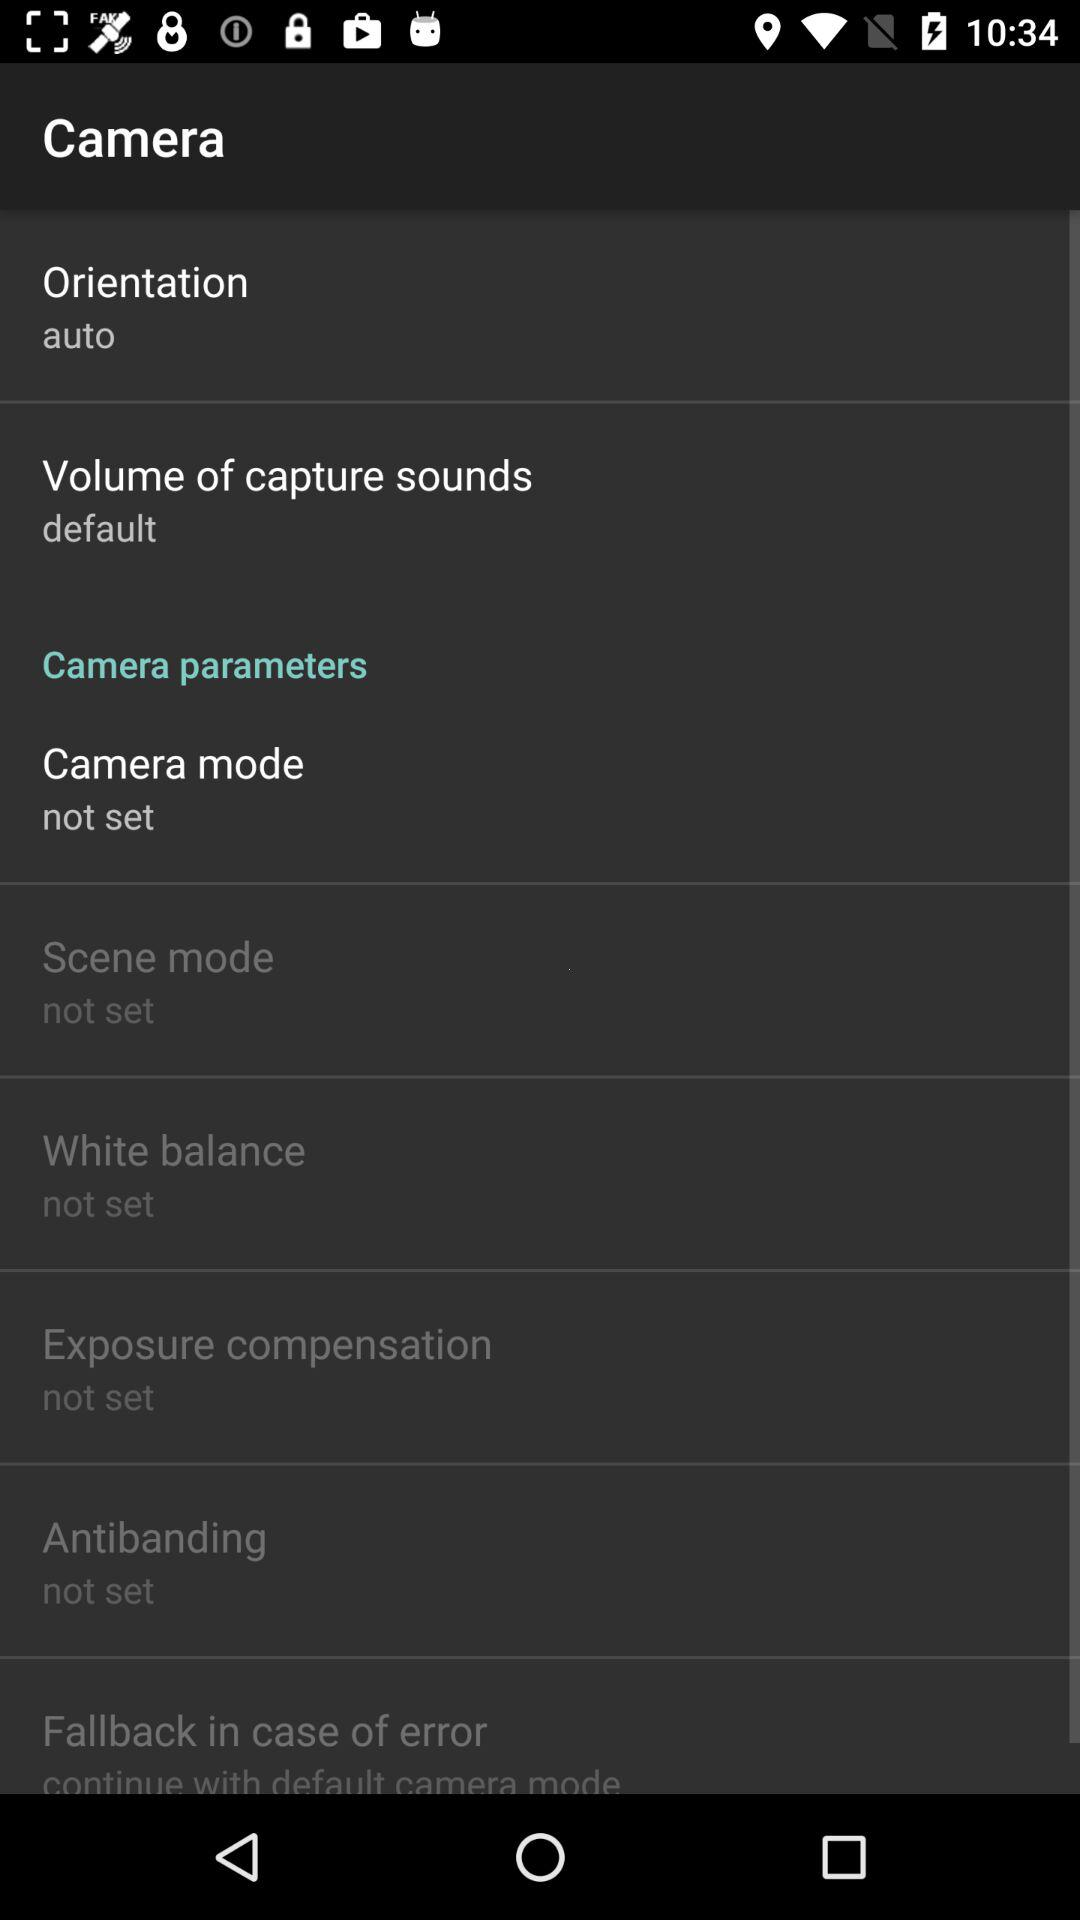What is the setting for the orientation? The setting for the orientation is "auto". 